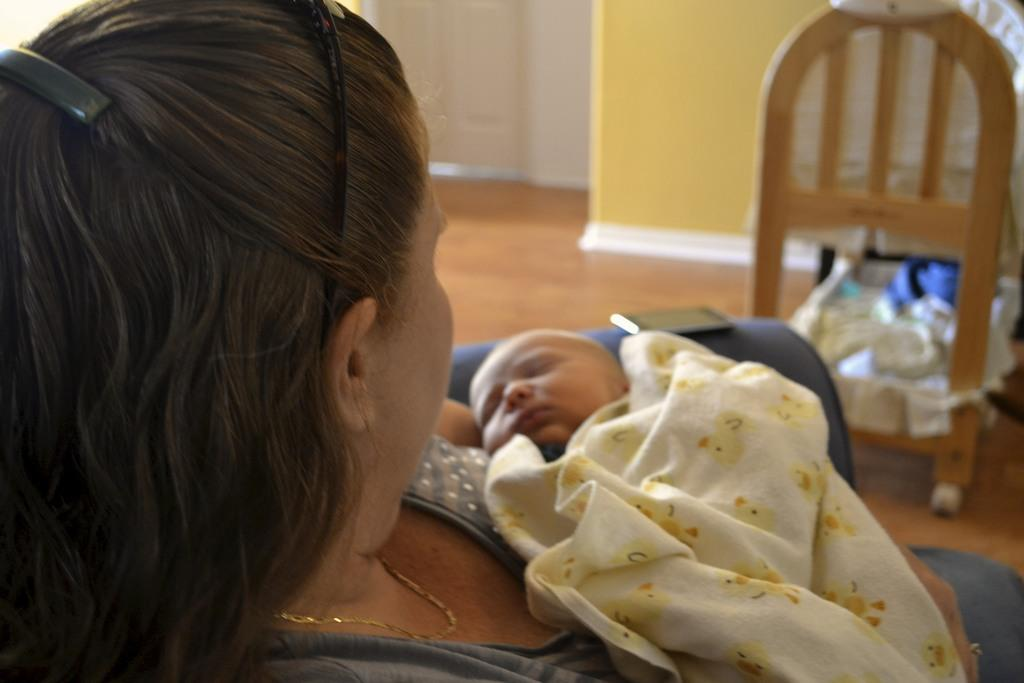Who is present in the image? There is a woman in the image. What is the woman holding? The woman is holding a baby. What can be seen hanging above the baby? There is a mobile in the image. On what surface is the scene taking place? The scene is taking place on a floor. What type of plastic material is used to make the baby in the image? The baby in the image is not made of plastic; it is a real baby. 